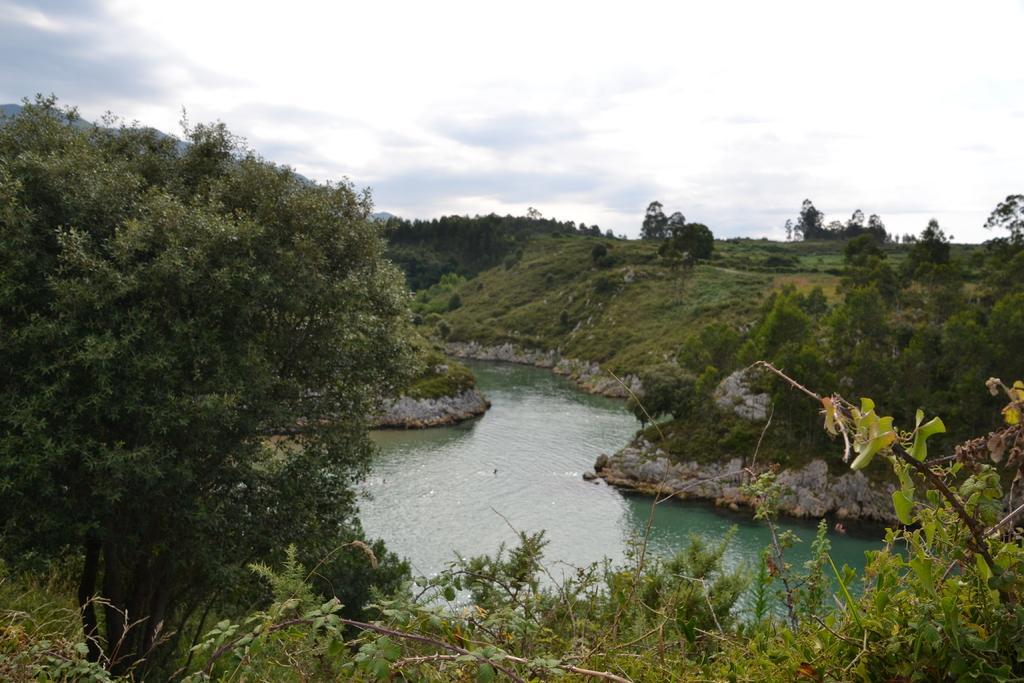How would you summarize this image in a sentence or two? This is the picture of a place where we have a river and around there are some plants, trees and some grass. 